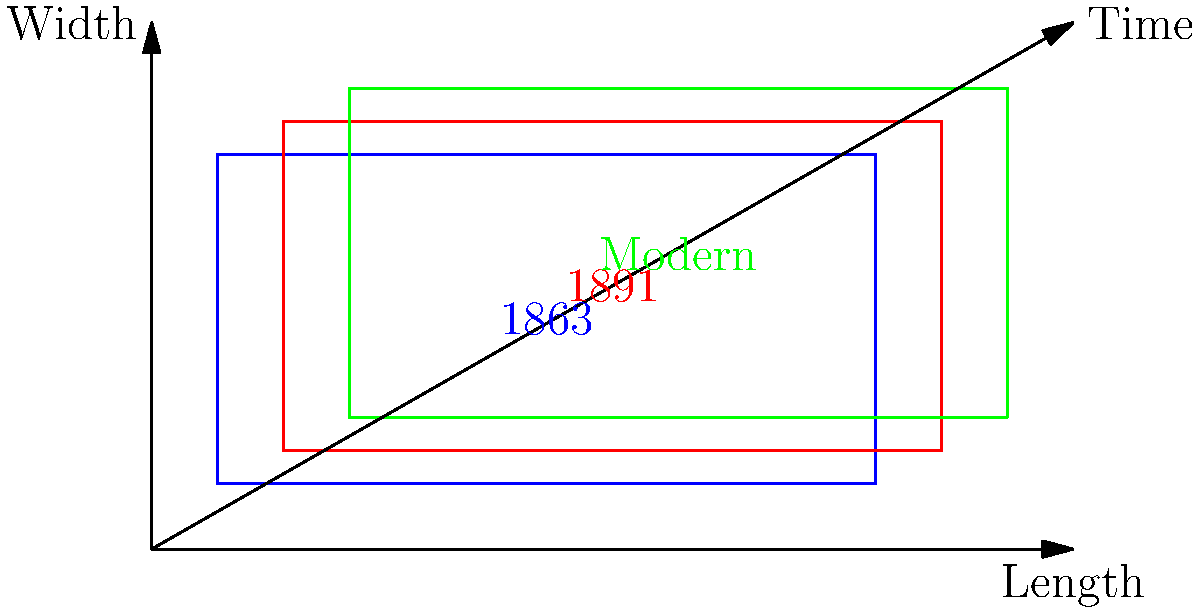Based on the diagram showing the evolution of football field dimensions over time, which trend can be observed regarding the size of the field from 1863 to the modern era? To answer this question, let's analyze the diagram step-by-step:

1. The diagram shows three rectangles representing football field dimensions at different points in time:
   - Blue rectangle: 1863 field
   - Red rectangle: 1891 field
   - Green rectangle: Modern field

2. Observe the position of each rectangle:
   - The 1863 field (blue) is the smallest and positioned at the bottom-left.
   - The 1891 field (red) is slightly larger and shifted up and to the right.
   - The modern field (green) is the largest and positioned at the top-right.

3. The arrows indicate that:
   - The x-axis represents the length of the field
   - The y-axis represents the width of the field
   - The diagonal arrow represents the passage of time

4. Comparing the rectangles, we can see that:
   - Both the length and width increase from 1863 to 1891
   - Both dimensions increase again from 1891 to the modern era

5. This consistent increase in both length and width over time indicates a clear trend of the football field becoming larger throughout its evolution.

Therefore, the observed trend is that the overall size of the football field has increased from 1863 to the modern era.
Answer: Increasing field size 